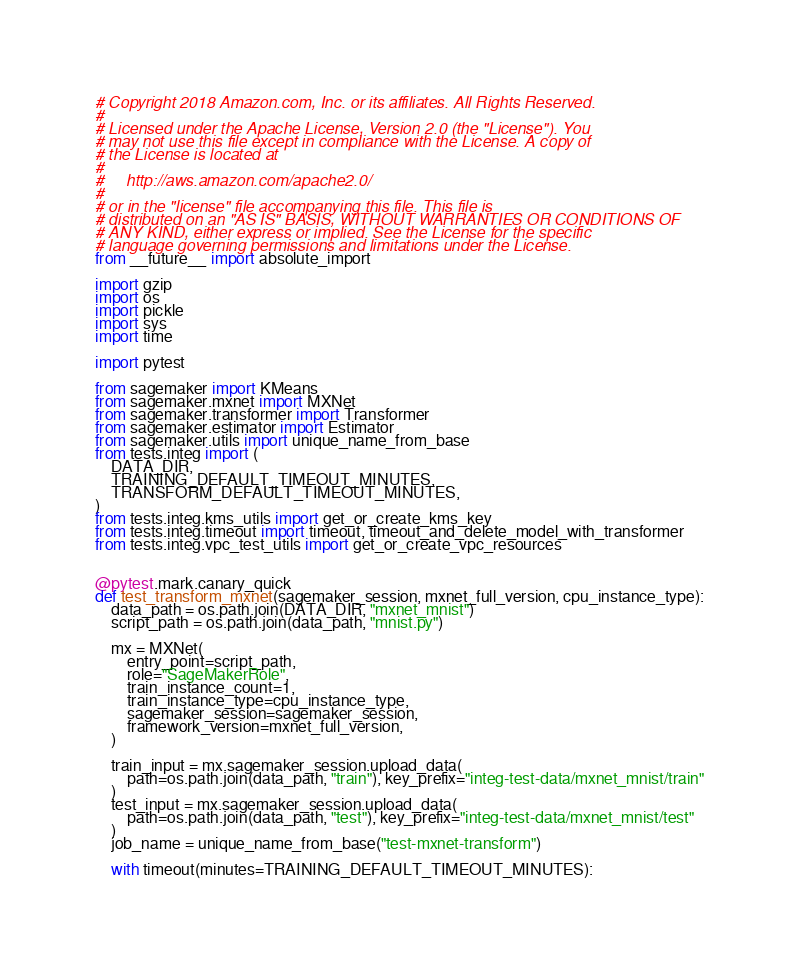Convert code to text. <code><loc_0><loc_0><loc_500><loc_500><_Python_># Copyright 2018 Amazon.com, Inc. or its affiliates. All Rights Reserved.
#
# Licensed under the Apache License, Version 2.0 (the "License"). You
# may not use this file except in compliance with the License. A copy of
# the License is located at
#
#     http://aws.amazon.com/apache2.0/
#
# or in the "license" file accompanying this file. This file is
# distributed on an "AS IS" BASIS, WITHOUT WARRANTIES OR CONDITIONS OF
# ANY KIND, either express or implied. See the License for the specific
# language governing permissions and limitations under the License.
from __future__ import absolute_import

import gzip
import os
import pickle
import sys
import time

import pytest

from sagemaker import KMeans
from sagemaker.mxnet import MXNet
from sagemaker.transformer import Transformer
from sagemaker.estimator import Estimator
from sagemaker.utils import unique_name_from_base
from tests.integ import (
    DATA_DIR,
    TRAINING_DEFAULT_TIMEOUT_MINUTES,
    TRANSFORM_DEFAULT_TIMEOUT_MINUTES,
)
from tests.integ.kms_utils import get_or_create_kms_key
from tests.integ.timeout import timeout, timeout_and_delete_model_with_transformer
from tests.integ.vpc_test_utils import get_or_create_vpc_resources


@pytest.mark.canary_quick
def test_transform_mxnet(sagemaker_session, mxnet_full_version, cpu_instance_type):
    data_path = os.path.join(DATA_DIR, "mxnet_mnist")
    script_path = os.path.join(data_path, "mnist.py")

    mx = MXNet(
        entry_point=script_path,
        role="SageMakerRole",
        train_instance_count=1,
        train_instance_type=cpu_instance_type,
        sagemaker_session=sagemaker_session,
        framework_version=mxnet_full_version,
    )

    train_input = mx.sagemaker_session.upload_data(
        path=os.path.join(data_path, "train"), key_prefix="integ-test-data/mxnet_mnist/train"
    )
    test_input = mx.sagemaker_session.upload_data(
        path=os.path.join(data_path, "test"), key_prefix="integ-test-data/mxnet_mnist/test"
    )
    job_name = unique_name_from_base("test-mxnet-transform")

    with timeout(minutes=TRAINING_DEFAULT_TIMEOUT_MINUTES):</code> 